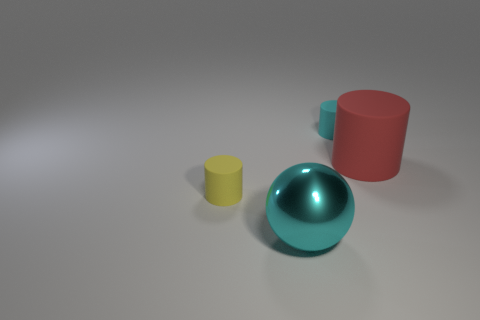Do the cyan sphere and the red thing have the same size?
Keep it short and to the point. Yes. What shape is the large object that is behind the large cyan metal sphere?
Provide a short and direct response. Cylinder. The cylinder in front of the large thing to the right of the big ball is what color?
Keep it short and to the point. Yellow. There is a tiny yellow thing to the left of the large shiny object; is its shape the same as the large object that is in front of the big rubber object?
Offer a terse response. No. What is the shape of the yellow thing that is the same size as the cyan matte object?
Ensure brevity in your answer.  Cylinder. The tiny thing that is the same material as the small cyan cylinder is what color?
Offer a very short reply. Yellow. There is a large red matte thing; does it have the same shape as the small matte object to the right of the small yellow cylinder?
Give a very brief answer. Yes. What material is the object that is the same size as the red matte cylinder?
Your response must be concise. Metal. Are there any other small things of the same color as the shiny thing?
Your answer should be compact. Yes. What is the shape of the object that is on the right side of the cyan sphere and in front of the cyan rubber object?
Offer a very short reply. Cylinder. 